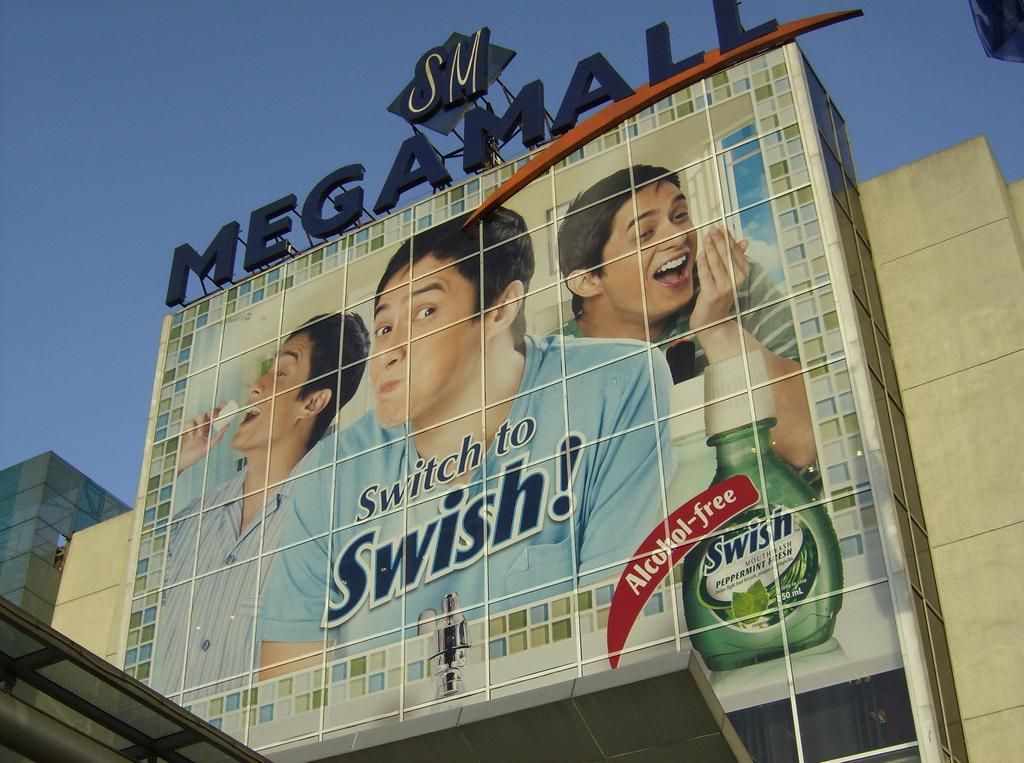What is located in the foreground of the image? There is a poster and text on a building in the foreground of the image. What can be seen in the background of the image? The sky is visible at the top of the image. Can you see any mountains in the image? There are no mountains present in the image. What color is the crayon used to write the text on the building? There is no crayon mentioned or visible in the image; the text appears to be printed or written with a different medium. 